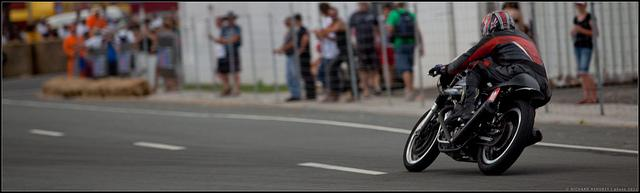Why is the rider's head covered? Please explain your reasoning. protection. The driver wants to protect against concussions. 